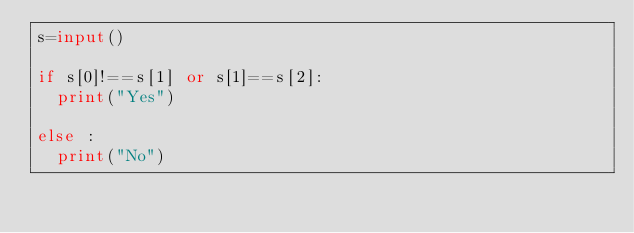Convert code to text. <code><loc_0><loc_0><loc_500><loc_500><_Python_>s=input()

if s[0]!==s[1] or s[1]==s[2]:
  print("Yes")
  
else :
  print("No")
</code> 